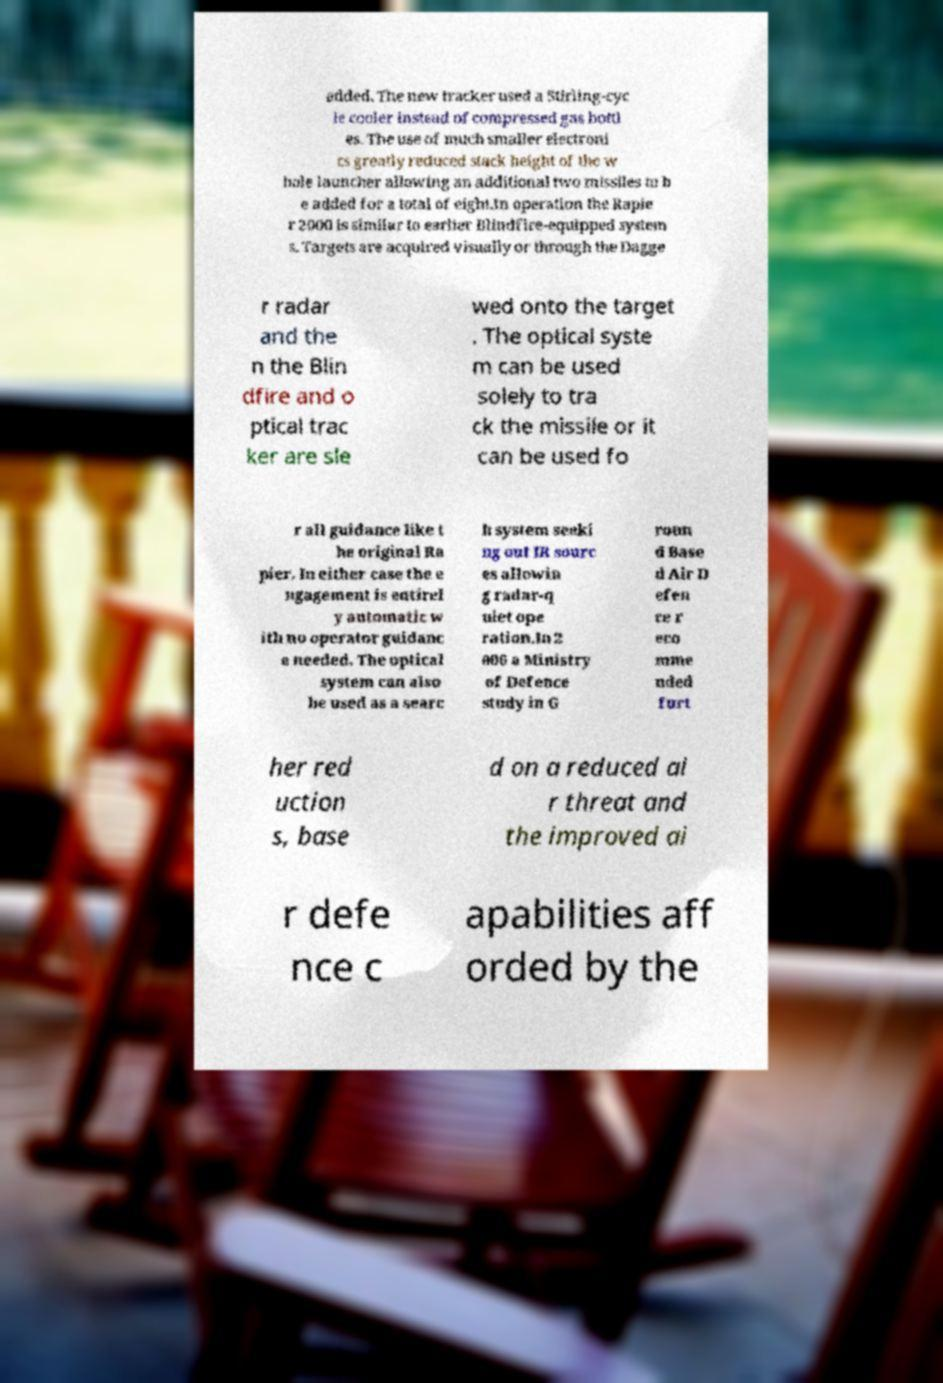Could you assist in decoding the text presented in this image and type it out clearly? added. The new tracker used a Stirling-cyc le cooler instead of compressed gas bottl es. The use of much smaller electroni cs greatly reduced stack height of the w hole launcher allowing an additional two missiles to b e added for a total of eight.In operation the Rapie r 2000 is similar to earlier Blindfire-equipped system s. Targets are acquired visually or through the Dagge r radar and the n the Blin dfire and o ptical trac ker are sle wed onto the target . The optical syste m can be used solely to tra ck the missile or it can be used fo r all guidance like t he original Ra pier. In either case the e ngagement is entirel y automatic w ith no operator guidanc e needed. The optical system can also be used as a searc h system seeki ng out IR sourc es allowin g radar-q uiet ope ration.In 2 006 a Ministry of Defence study in G roun d Base d Air D efen ce r eco mme nded furt her red uction s, base d on a reduced ai r threat and the improved ai r defe nce c apabilities aff orded by the 